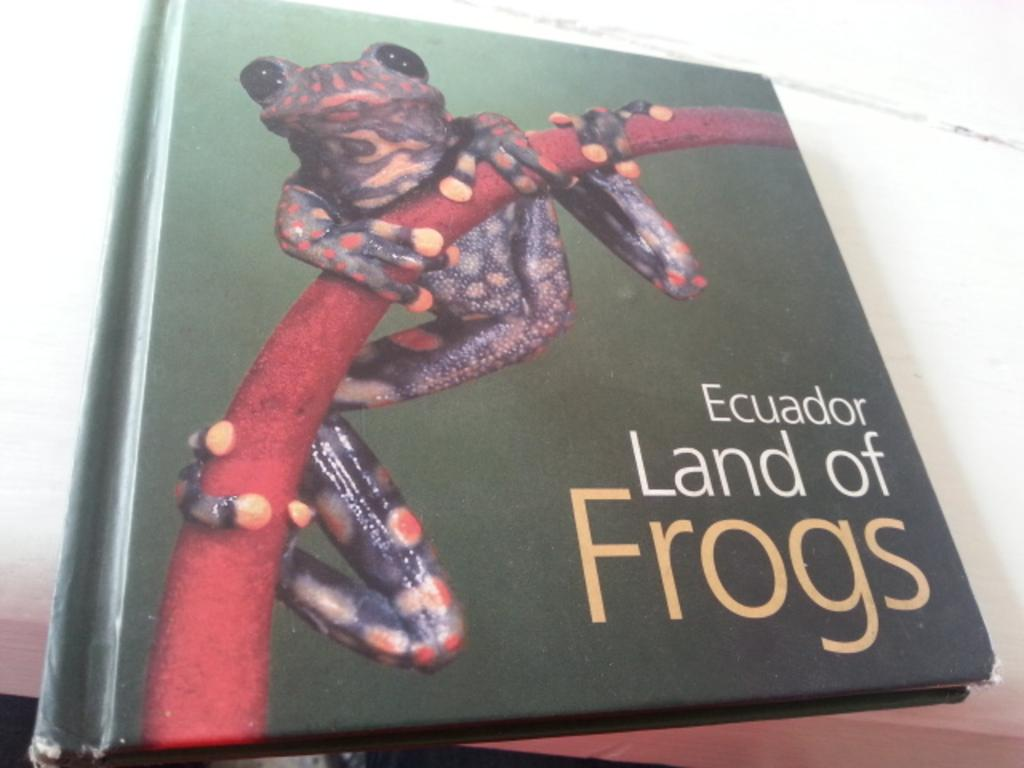<image>
Present a compact description of the photo's key features. A coffee table photography book is entitled Ecuador Land of Frogs. 